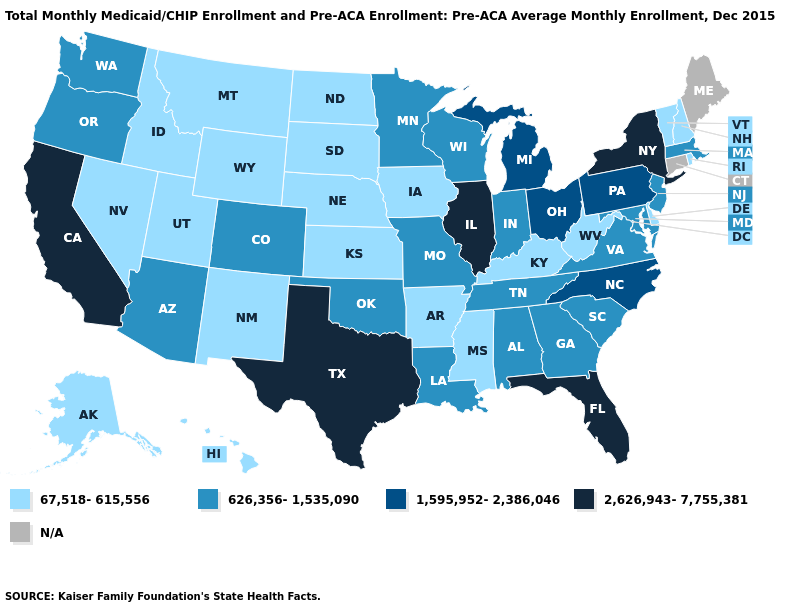What is the highest value in states that border Washington?
Give a very brief answer. 626,356-1,535,090. Does South Dakota have the highest value in the MidWest?
Be succinct. No. What is the value of Washington?
Short answer required. 626,356-1,535,090. What is the value of Montana?
Short answer required. 67,518-615,556. Name the states that have a value in the range 2,626,943-7,755,381?
Short answer required. California, Florida, Illinois, New York, Texas. What is the lowest value in the USA?
Keep it brief. 67,518-615,556. Name the states that have a value in the range 626,356-1,535,090?
Concise answer only. Alabama, Arizona, Colorado, Georgia, Indiana, Louisiana, Maryland, Massachusetts, Minnesota, Missouri, New Jersey, Oklahoma, Oregon, South Carolina, Tennessee, Virginia, Washington, Wisconsin. Name the states that have a value in the range 67,518-615,556?
Answer briefly. Alaska, Arkansas, Delaware, Hawaii, Idaho, Iowa, Kansas, Kentucky, Mississippi, Montana, Nebraska, Nevada, New Hampshire, New Mexico, North Dakota, Rhode Island, South Dakota, Utah, Vermont, West Virginia, Wyoming. Name the states that have a value in the range 2,626,943-7,755,381?
Keep it brief. California, Florida, Illinois, New York, Texas. How many symbols are there in the legend?
Be succinct. 5. Which states have the highest value in the USA?
Answer briefly. California, Florida, Illinois, New York, Texas. Among the states that border Minnesota , which have the lowest value?
Write a very short answer. Iowa, North Dakota, South Dakota. What is the value of Indiana?
Answer briefly. 626,356-1,535,090. Which states have the highest value in the USA?
Keep it brief. California, Florida, Illinois, New York, Texas. What is the value of West Virginia?
Short answer required. 67,518-615,556. 